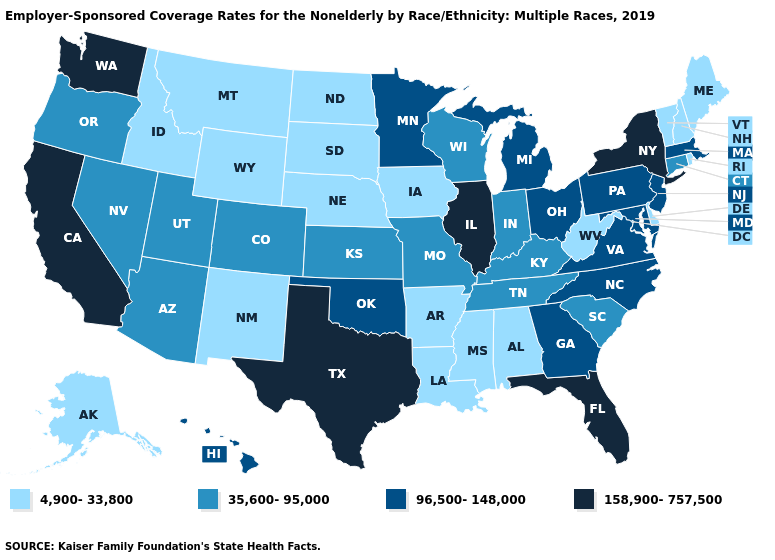Name the states that have a value in the range 35,600-95,000?
Quick response, please. Arizona, Colorado, Connecticut, Indiana, Kansas, Kentucky, Missouri, Nevada, Oregon, South Carolina, Tennessee, Utah, Wisconsin. What is the lowest value in the USA?
Quick response, please. 4,900-33,800. Name the states that have a value in the range 158,900-757,500?
Short answer required. California, Florida, Illinois, New York, Texas, Washington. What is the lowest value in states that border Tennessee?
Answer briefly. 4,900-33,800. Does Florida have the lowest value in the USA?
Short answer required. No. Which states have the highest value in the USA?
Be succinct. California, Florida, Illinois, New York, Texas, Washington. Does North Carolina have the lowest value in the USA?
Give a very brief answer. No. What is the value of South Dakota?
Short answer required. 4,900-33,800. What is the highest value in states that border Missouri?
Be succinct. 158,900-757,500. Name the states that have a value in the range 158,900-757,500?
Write a very short answer. California, Florida, Illinois, New York, Texas, Washington. What is the highest value in the USA?
Concise answer only. 158,900-757,500. Does Pennsylvania have the lowest value in the USA?
Answer briefly. No. Which states hav the highest value in the Northeast?
Be succinct. New York. Name the states that have a value in the range 158,900-757,500?
Quick response, please. California, Florida, Illinois, New York, Texas, Washington. How many symbols are there in the legend?
Keep it brief. 4. 